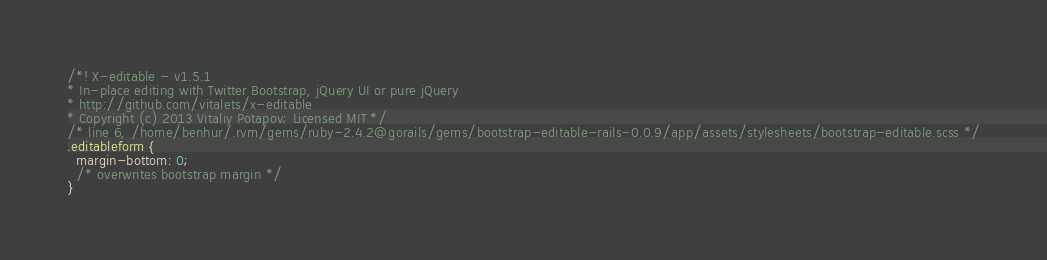<code> <loc_0><loc_0><loc_500><loc_500><_CSS_>/*! X-editable - v1.5.1 
* In-place editing with Twitter Bootstrap, jQuery UI or pure jQuery
* http://github.com/vitalets/x-editable
* Copyright (c) 2013 Vitaliy Potapov; Licensed MIT */
/* line 6, /home/benhur/.rvm/gems/ruby-2.4.2@gorails/gems/bootstrap-editable-rails-0.0.9/app/assets/stylesheets/bootstrap-editable.scss */
.editableform {
  margin-bottom: 0;
  /* overwrites bootstrap margin */
}
</code> 